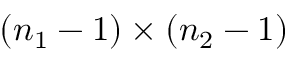Convert formula to latex. <formula><loc_0><loc_0><loc_500><loc_500>( n _ { 1 } - 1 ) \times ( n _ { 2 } - 1 )</formula> 